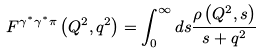<formula> <loc_0><loc_0><loc_500><loc_500>F ^ { \gamma ^ { * } \gamma ^ { * } \pi } \left ( Q ^ { 2 } , q ^ { 2 } \right ) = \int _ { 0 } ^ { \infty } d s \frac { \rho \left ( Q ^ { 2 } , s \right ) } { s + q ^ { 2 } }</formula> 